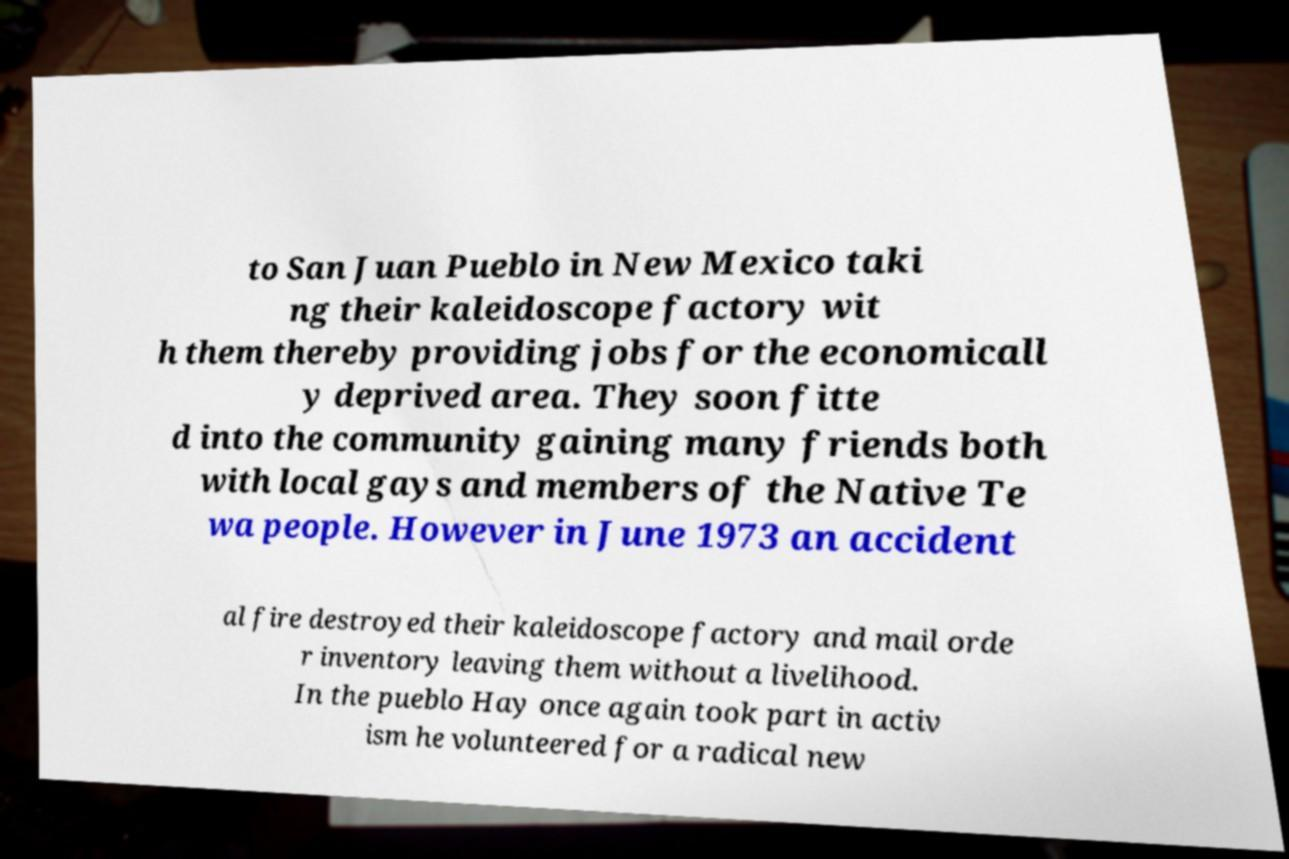What messages or text are displayed in this image? I need them in a readable, typed format. to San Juan Pueblo in New Mexico taki ng their kaleidoscope factory wit h them thereby providing jobs for the economicall y deprived area. They soon fitte d into the community gaining many friends both with local gays and members of the Native Te wa people. However in June 1973 an accident al fire destroyed their kaleidoscope factory and mail orde r inventory leaving them without a livelihood. In the pueblo Hay once again took part in activ ism he volunteered for a radical new 